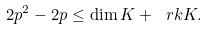Convert formula to latex. <formula><loc_0><loc_0><loc_500><loc_500>2 p ^ { 2 } - 2 p \leq \dim K + \ r k K .</formula> 